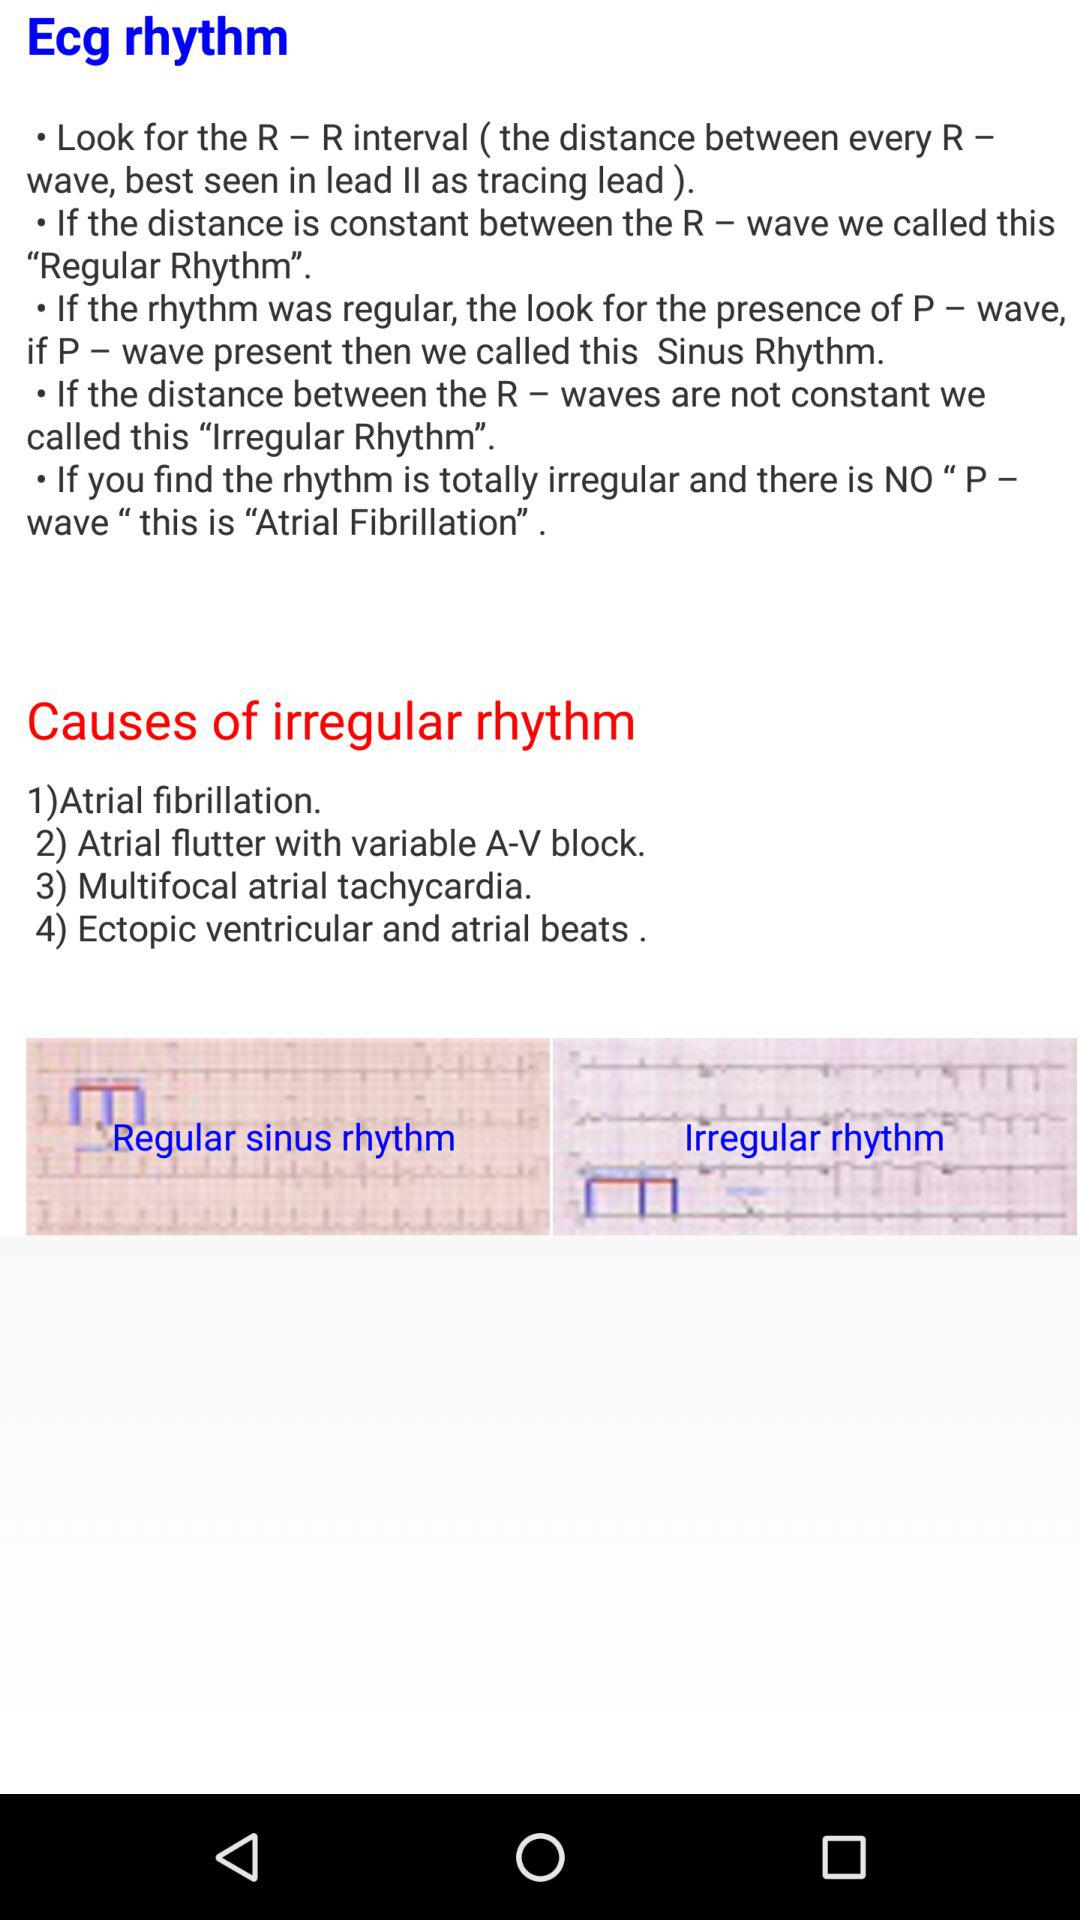What is the cause of the irregular rhythm? The causes of irregular rhythm are "Atrial fibrillation", "Atrial flutter with variable A-V block", "Multifocal atrial tachycardia" and "Ectopic ventricular and atrial beats". 